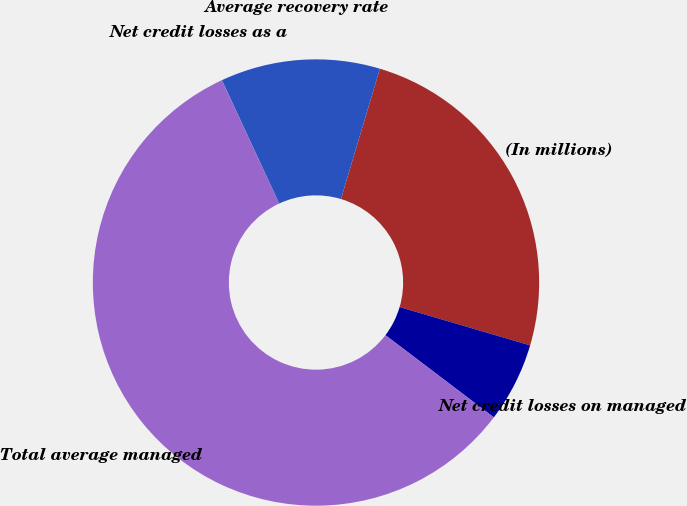<chart> <loc_0><loc_0><loc_500><loc_500><pie_chart><fcel>(In millions)<fcel>Net credit losses on managed<fcel>Total average managed<fcel>Net credit losses as a<fcel>Average recovery rate<nl><fcel>24.92%<fcel>5.78%<fcel>57.74%<fcel>0.01%<fcel>11.55%<nl></chart> 